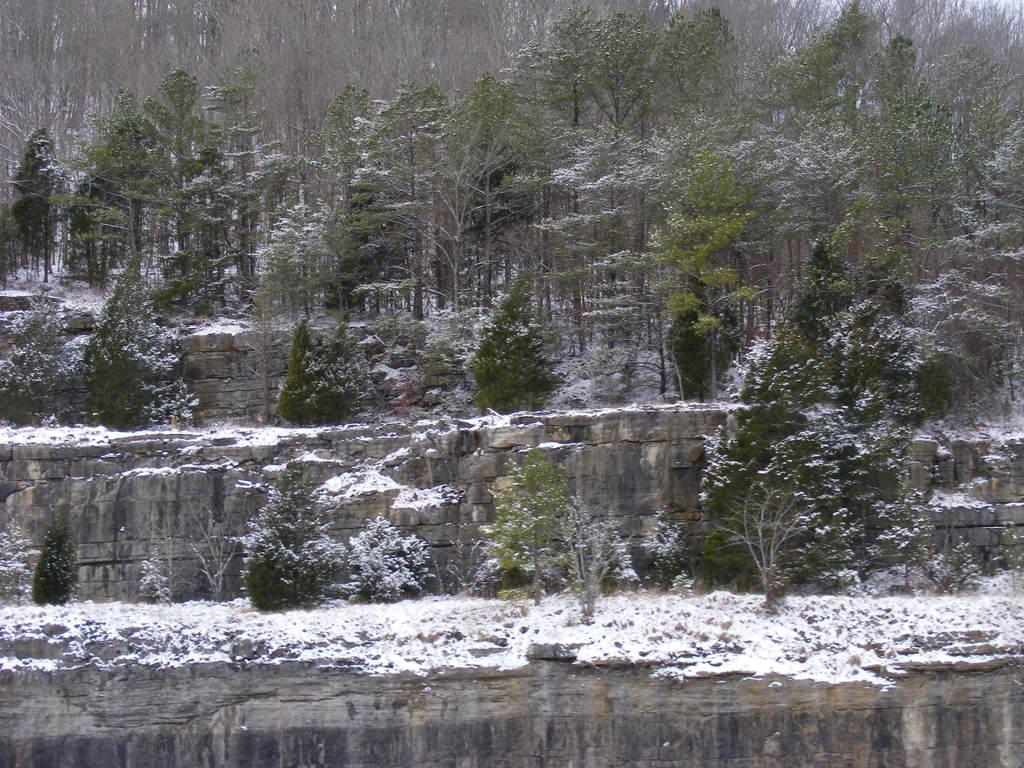What is one of the natural elements present in the image? There is water in the image. What type of weather condition can be observed in the image? There is snow in the image, indicating a cold environment. What type of vegetation is present in the image? There are trees in the image. What type of ground surface is present in the image? There are stones in the image. What is visible in the background of the image? The sky is visible in the image. What time of day is it in the image, and where is the jail located? The time of day cannot be determined from the image, and there is no jail present in the image. 